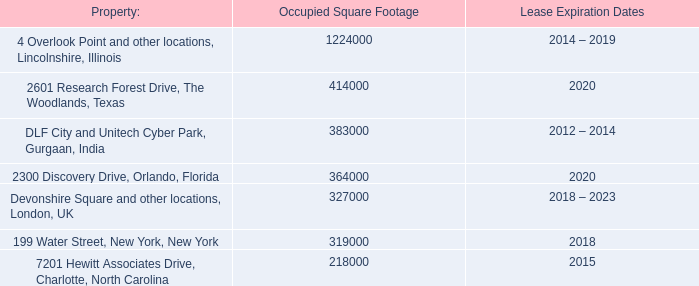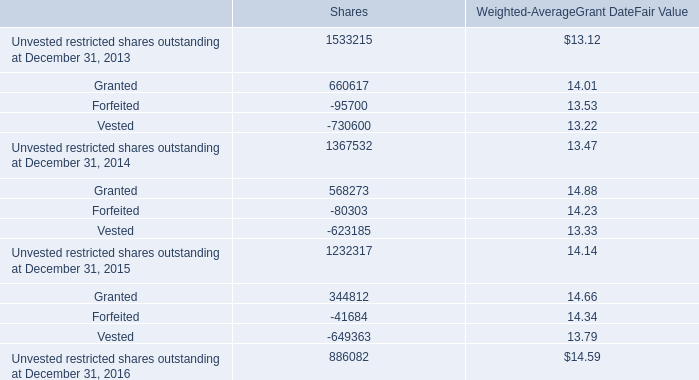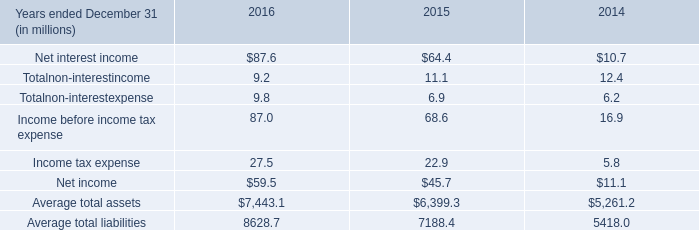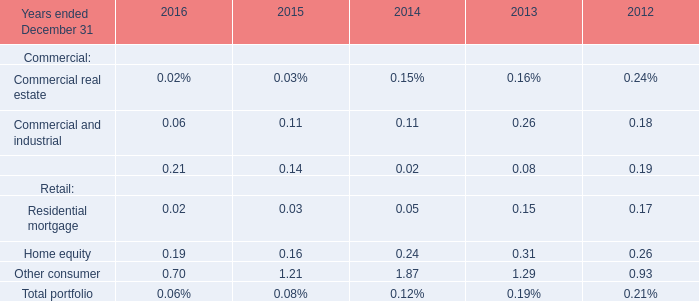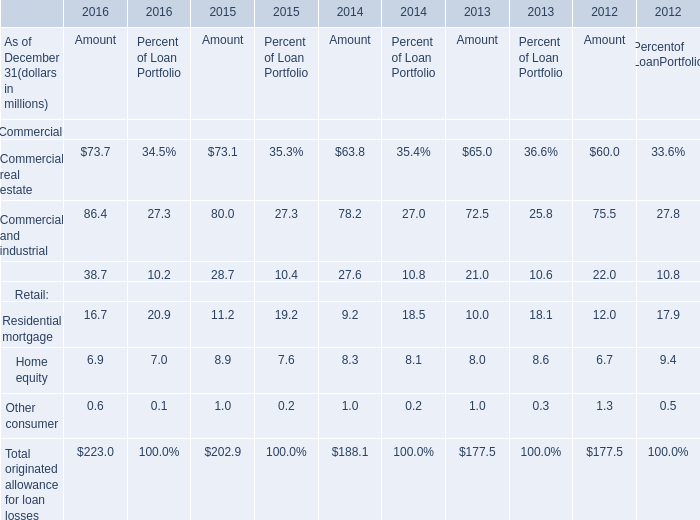What's the total amount of the Equipment financing for Amount in the years where Commercial and industrial for Amount is greater than 79? (in million) 
Computations: (38.7 + 28.7)
Answer: 67.4. 